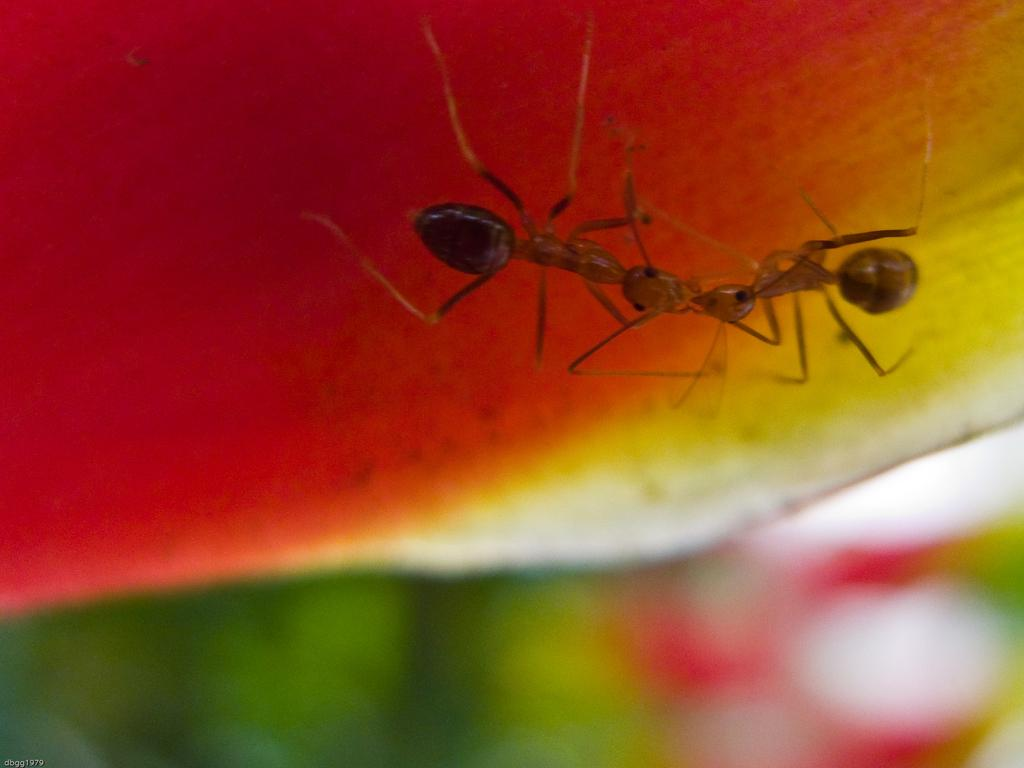How many ants are visible in the image? There are two ants in the image. What are the ants doing in the image? The ants are on a watermelon. What type of vest is the ant wearing in the image? There are no vests present in the image, and the ants are not wearing any clothing. 